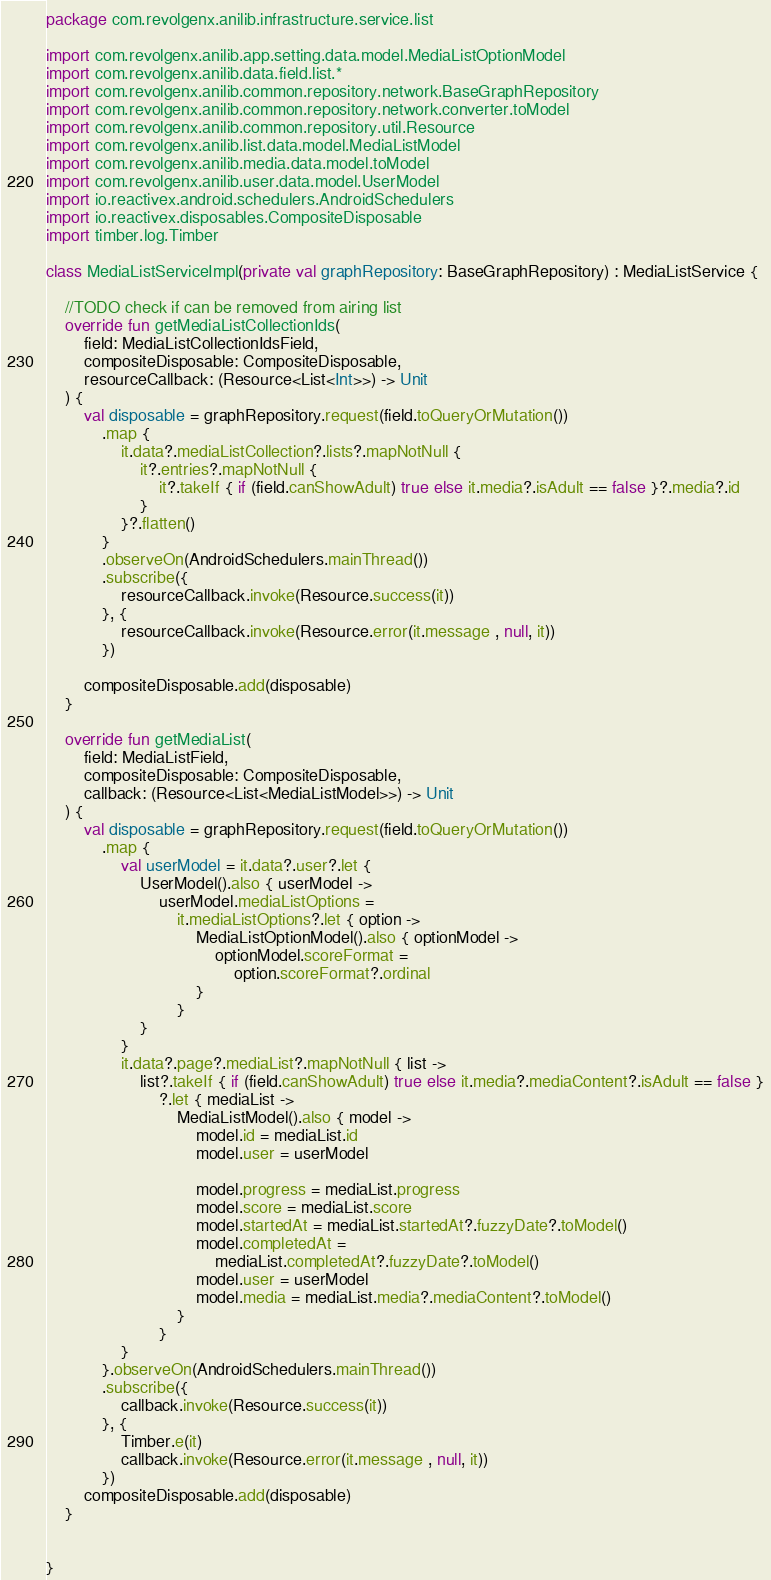<code> <loc_0><loc_0><loc_500><loc_500><_Kotlin_>package com.revolgenx.anilib.infrastructure.service.list

import com.revolgenx.anilib.app.setting.data.model.MediaListOptionModel
import com.revolgenx.anilib.data.field.list.*
import com.revolgenx.anilib.common.repository.network.BaseGraphRepository
import com.revolgenx.anilib.common.repository.network.converter.toModel
import com.revolgenx.anilib.common.repository.util.Resource
import com.revolgenx.anilib.list.data.model.MediaListModel
import com.revolgenx.anilib.media.data.model.toModel
import com.revolgenx.anilib.user.data.model.UserModel
import io.reactivex.android.schedulers.AndroidSchedulers
import io.reactivex.disposables.CompositeDisposable
import timber.log.Timber

class MediaListServiceImpl(private val graphRepository: BaseGraphRepository) : MediaListService {

    //TODO check if can be removed from airing list
    override fun getMediaListCollectionIds(
        field: MediaListCollectionIdsField,
        compositeDisposable: CompositeDisposable,
        resourceCallback: (Resource<List<Int>>) -> Unit
    ) {
        val disposable = graphRepository.request(field.toQueryOrMutation())
            .map {
                it.data?.mediaListCollection?.lists?.mapNotNull {
                    it?.entries?.mapNotNull {
                        it?.takeIf { if (field.canShowAdult) true else it.media?.isAdult == false }?.media?.id
                    }
                }?.flatten()
            }
            .observeOn(AndroidSchedulers.mainThread())
            .subscribe({
                resourceCallback.invoke(Resource.success(it))
            }, {
                resourceCallback.invoke(Resource.error(it.message , null, it))
            })

        compositeDisposable.add(disposable)
    }

    override fun getMediaList(
        field: MediaListField,
        compositeDisposable: CompositeDisposable,
        callback: (Resource<List<MediaListModel>>) -> Unit
    ) {
        val disposable = graphRepository.request(field.toQueryOrMutation())
            .map {
                val userModel = it.data?.user?.let {
                    UserModel().also { userModel ->
                        userModel.mediaListOptions =
                            it.mediaListOptions?.let { option ->
                                MediaListOptionModel().also { optionModel ->
                                    optionModel.scoreFormat =
                                        option.scoreFormat?.ordinal
                                }
                            }
                    }
                }
                it.data?.page?.mediaList?.mapNotNull { list ->
                    list?.takeIf { if (field.canShowAdult) true else it.media?.mediaContent?.isAdult == false }
                        ?.let { mediaList ->
                            MediaListModel().also { model ->
                                model.id = mediaList.id
                                model.user = userModel

                                model.progress = mediaList.progress
                                model.score = mediaList.score
                                model.startedAt = mediaList.startedAt?.fuzzyDate?.toModel()
                                model.completedAt =
                                    mediaList.completedAt?.fuzzyDate?.toModel()
                                model.user = userModel
                                model.media = mediaList.media?.mediaContent?.toModel()
                            }
                        }
                }
            }.observeOn(AndroidSchedulers.mainThread())
            .subscribe({
                callback.invoke(Resource.success(it))
            }, {
                Timber.e(it)
                callback.invoke(Resource.error(it.message , null, it))
            })
        compositeDisposable.add(disposable)
    }


}</code> 